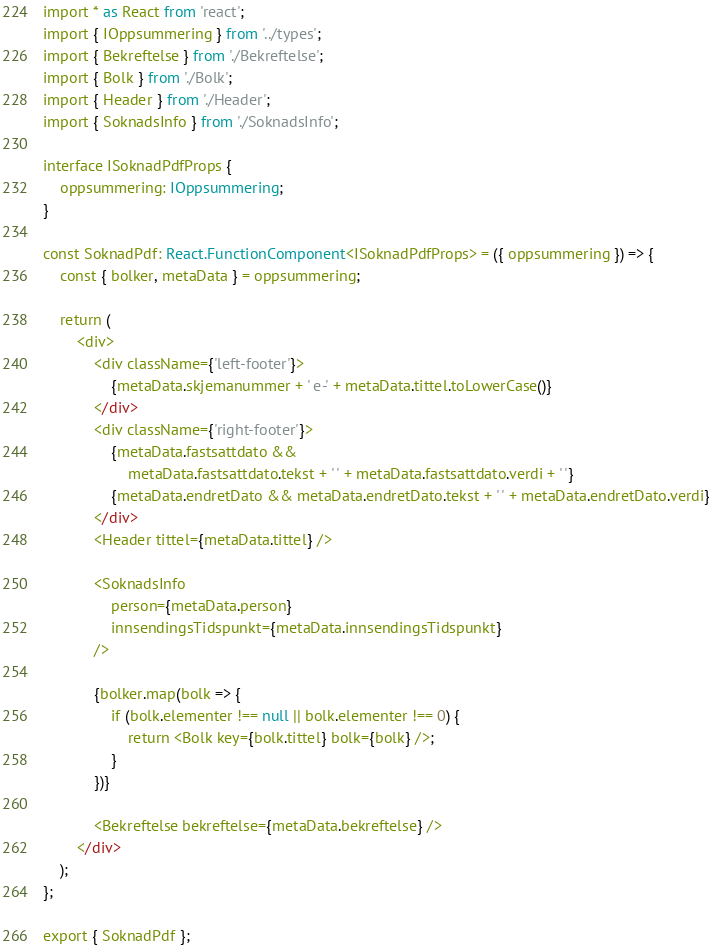<code> <loc_0><loc_0><loc_500><loc_500><_TypeScript_>import * as React from 'react';
import { IOppsummering } from '../types';
import { Bekreftelse } from './Bekreftelse';
import { Bolk } from './Bolk';
import { Header } from './Header';
import { SoknadsInfo } from './SoknadsInfo';

interface ISoknadPdfProps {
    oppsummering: IOppsummering;
}

const SoknadPdf: React.FunctionComponent<ISoknadPdfProps> = ({ oppsummering }) => {
    const { bolker, metaData } = oppsummering;

    return (
        <div>
            <div className={'left-footer'}>
                {metaData.skjemanummer + ' e-' + metaData.tittel.toLowerCase()}
            </div>
            <div className={'right-footer'}>
                {metaData.fastsattdato &&
                    metaData.fastsattdato.tekst + ' ' + metaData.fastsattdato.verdi + ' '}
                {metaData.endretDato && metaData.endretDato.tekst + ' ' + metaData.endretDato.verdi}
            </div>
            <Header tittel={metaData.tittel} />

            <SoknadsInfo
                person={metaData.person}
                innsendingsTidspunkt={metaData.innsendingsTidspunkt}
            />

            {bolker.map(bolk => {
                if (bolk.elementer !== null || bolk.elementer !== 0) {
                    return <Bolk key={bolk.tittel} bolk={bolk} />;
                }
            })}

            <Bekreftelse bekreftelse={metaData.bekreftelse} />
        </div>
    );
};

export { SoknadPdf };
</code> 